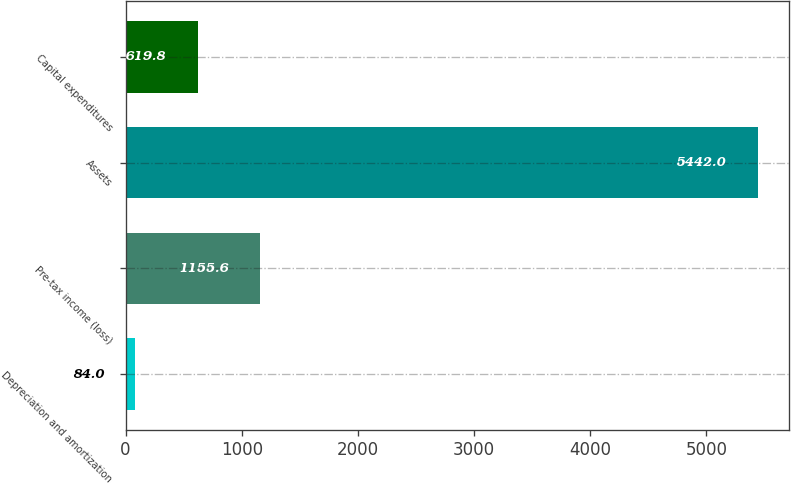<chart> <loc_0><loc_0><loc_500><loc_500><bar_chart><fcel>Depreciation and amortization<fcel>Pre-tax income (loss)<fcel>Assets<fcel>Capital expenditures<nl><fcel>84<fcel>1155.6<fcel>5442<fcel>619.8<nl></chart> 